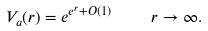Convert formula to latex. <formula><loc_0><loc_0><loc_500><loc_500>V _ { a } ( r ) = e ^ { e ^ { r } + O ( 1 ) } \quad \, r \to \infty .</formula> 